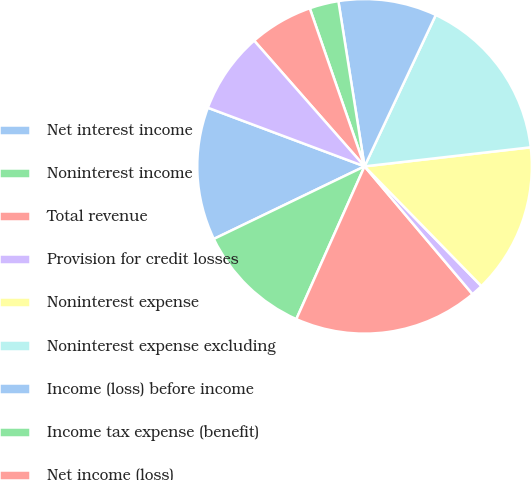<chart> <loc_0><loc_0><loc_500><loc_500><pie_chart><fcel>Net interest income<fcel>Noninterest income<fcel>Total revenue<fcel>Provision for credit losses<fcel>Noninterest expense<fcel>Noninterest expense excluding<fcel>Income (loss) before income<fcel>Income tax expense (benefit)<fcel>Net income (loss)<fcel>Net income excluding goodwill<nl><fcel>12.84%<fcel>11.17%<fcel>17.85%<fcel>1.14%<fcel>14.51%<fcel>16.18%<fcel>9.5%<fcel>2.81%<fcel>6.16%<fcel>7.83%<nl></chart> 